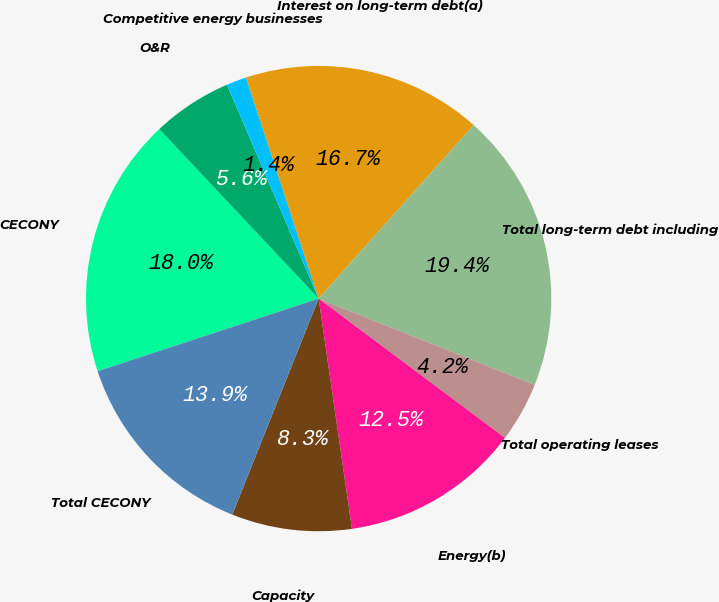Convert chart to OTSL. <chart><loc_0><loc_0><loc_500><loc_500><pie_chart><fcel>CECONY<fcel>O&R<fcel>Competitive energy businesses<fcel>Interest on long-term debt(a)<fcel>Total long-term debt including<fcel>Total operating leases<fcel>Energy(b)<fcel>Capacity<fcel>Total CECONY<nl><fcel>18.05%<fcel>5.56%<fcel>1.4%<fcel>16.66%<fcel>19.44%<fcel>4.17%<fcel>12.5%<fcel>8.34%<fcel>13.89%<nl></chart> 